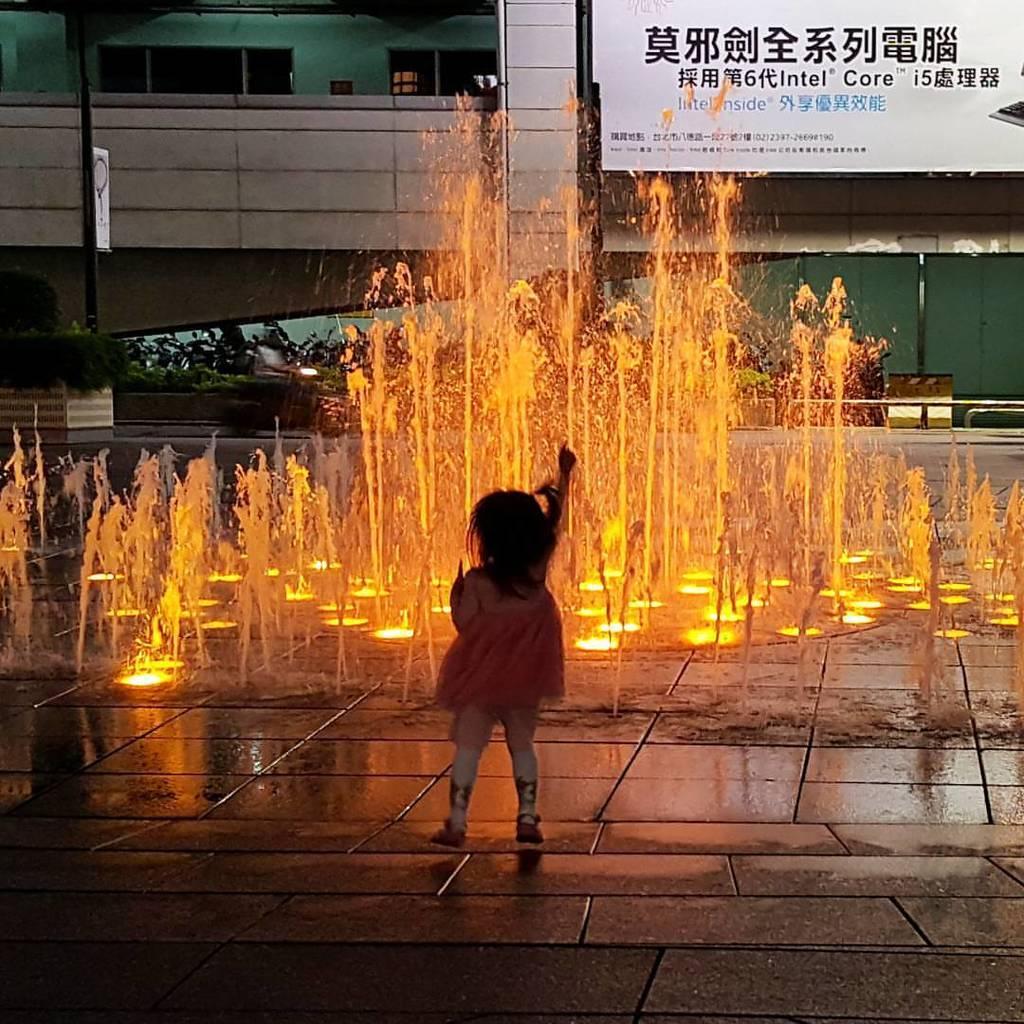Describe this image in one or two sentences. Here we can see girl and water fountain. Background there is a hoarding, poles, board and plants. 